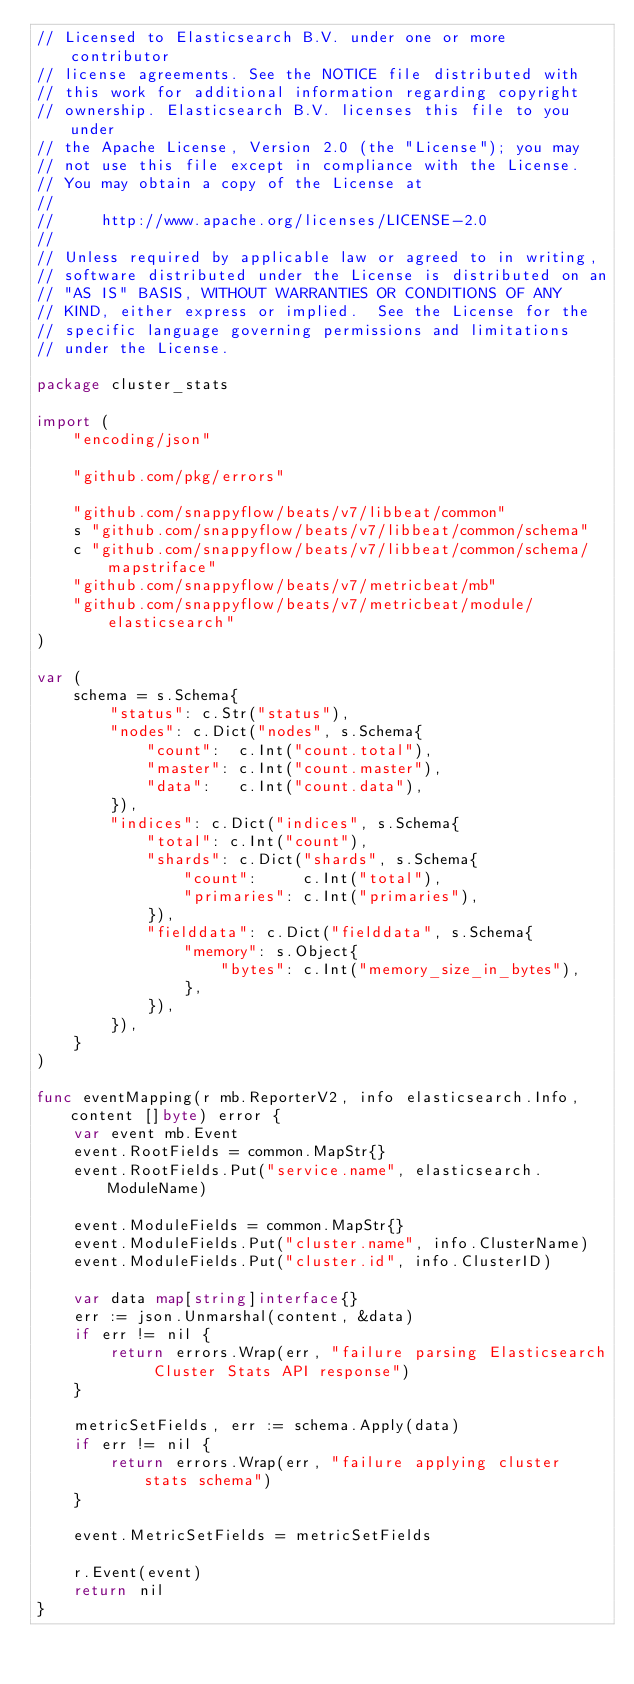Convert code to text. <code><loc_0><loc_0><loc_500><loc_500><_Go_>// Licensed to Elasticsearch B.V. under one or more contributor
// license agreements. See the NOTICE file distributed with
// this work for additional information regarding copyright
// ownership. Elasticsearch B.V. licenses this file to you under
// the Apache License, Version 2.0 (the "License"); you may
// not use this file except in compliance with the License.
// You may obtain a copy of the License at
//
//     http://www.apache.org/licenses/LICENSE-2.0
//
// Unless required by applicable law or agreed to in writing,
// software distributed under the License is distributed on an
// "AS IS" BASIS, WITHOUT WARRANTIES OR CONDITIONS OF ANY
// KIND, either express or implied.  See the License for the
// specific language governing permissions and limitations
// under the License.

package cluster_stats

import (
	"encoding/json"

	"github.com/pkg/errors"

	"github.com/snappyflow/beats/v7/libbeat/common"
	s "github.com/snappyflow/beats/v7/libbeat/common/schema"
	c "github.com/snappyflow/beats/v7/libbeat/common/schema/mapstriface"
	"github.com/snappyflow/beats/v7/metricbeat/mb"
	"github.com/snappyflow/beats/v7/metricbeat/module/elasticsearch"
)

var (
	schema = s.Schema{
		"status": c.Str("status"),
		"nodes": c.Dict("nodes", s.Schema{
			"count":  c.Int("count.total"),
			"master": c.Int("count.master"),
			"data":   c.Int("count.data"),
		}),
		"indices": c.Dict("indices", s.Schema{
			"total": c.Int("count"),
			"shards": c.Dict("shards", s.Schema{
				"count":     c.Int("total"),
				"primaries": c.Int("primaries"),
			}),
			"fielddata": c.Dict("fielddata", s.Schema{
				"memory": s.Object{
					"bytes": c.Int("memory_size_in_bytes"),
				},
			}),
		}),
	}
)

func eventMapping(r mb.ReporterV2, info elasticsearch.Info, content []byte) error {
	var event mb.Event
	event.RootFields = common.MapStr{}
	event.RootFields.Put("service.name", elasticsearch.ModuleName)

	event.ModuleFields = common.MapStr{}
	event.ModuleFields.Put("cluster.name", info.ClusterName)
	event.ModuleFields.Put("cluster.id", info.ClusterID)

	var data map[string]interface{}
	err := json.Unmarshal(content, &data)
	if err != nil {
		return errors.Wrap(err, "failure parsing Elasticsearch Cluster Stats API response")
	}

	metricSetFields, err := schema.Apply(data)
	if err != nil {
		return errors.Wrap(err, "failure applying cluster stats schema")
	}

	event.MetricSetFields = metricSetFields

	r.Event(event)
	return nil
}
</code> 